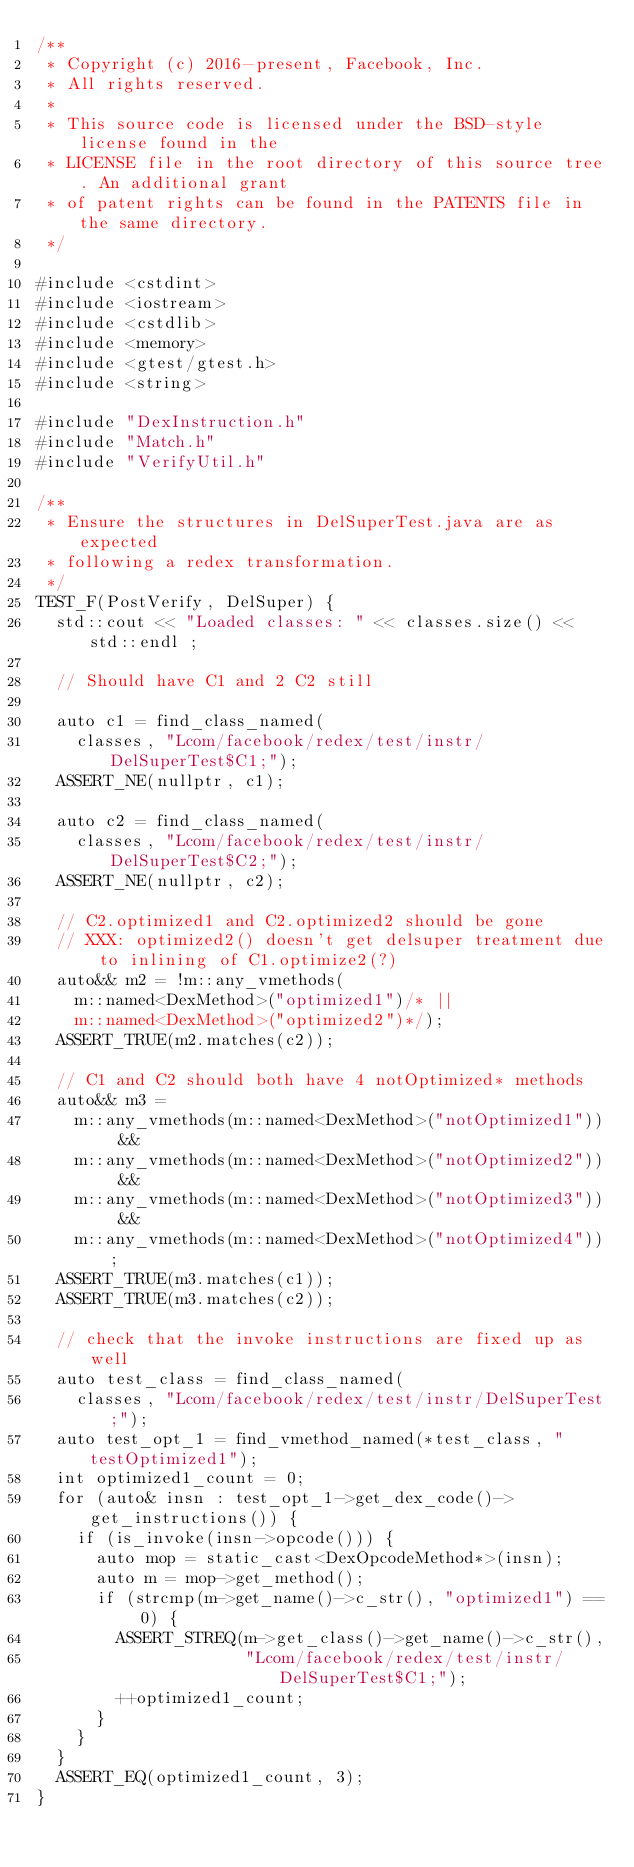Convert code to text. <code><loc_0><loc_0><loc_500><loc_500><_C++_>/**
 * Copyright (c) 2016-present, Facebook, Inc.
 * All rights reserved.
 *
 * This source code is licensed under the BSD-style license found in the
 * LICENSE file in the root directory of this source tree. An additional grant
 * of patent rights can be found in the PATENTS file in the same directory.
 */

#include <cstdint>
#include <iostream>
#include <cstdlib>
#include <memory>
#include <gtest/gtest.h>
#include <string>

#include "DexInstruction.h"
#include "Match.h"
#include "VerifyUtil.h"

/**
 * Ensure the structures in DelSuperTest.java are as expected
 * following a redex transformation.
 */
TEST_F(PostVerify, DelSuper) {
  std::cout << "Loaded classes: " << classes.size() << std::endl ;

  // Should have C1 and 2 C2 still

  auto c1 = find_class_named(
    classes, "Lcom/facebook/redex/test/instr/DelSuperTest$C1;");
  ASSERT_NE(nullptr, c1);

  auto c2 = find_class_named(
    classes, "Lcom/facebook/redex/test/instr/DelSuperTest$C2;");
  ASSERT_NE(nullptr, c2);

  // C2.optimized1 and C2.optimized2 should be gone
  // XXX: optimized2() doesn't get delsuper treatment due to inlining of C1.optimize2(?)
  auto&& m2 = !m::any_vmethods(
    m::named<DexMethod>("optimized1")/* ||
    m::named<DexMethod>("optimized2")*/);
  ASSERT_TRUE(m2.matches(c2));

  // C1 and C2 should both have 4 notOptimized* methods
  auto&& m3 =
    m::any_vmethods(m::named<DexMethod>("notOptimized1")) &&
    m::any_vmethods(m::named<DexMethod>("notOptimized2")) &&
    m::any_vmethods(m::named<DexMethod>("notOptimized3")) &&
    m::any_vmethods(m::named<DexMethod>("notOptimized4"));
  ASSERT_TRUE(m3.matches(c1));
  ASSERT_TRUE(m3.matches(c2));

  // check that the invoke instructions are fixed up as well
  auto test_class = find_class_named(
    classes, "Lcom/facebook/redex/test/instr/DelSuperTest;");
  auto test_opt_1 = find_vmethod_named(*test_class, "testOptimized1");
  int optimized1_count = 0;
  for (auto& insn : test_opt_1->get_dex_code()->get_instructions()) {
    if (is_invoke(insn->opcode())) {
      auto mop = static_cast<DexOpcodeMethod*>(insn);
      auto m = mop->get_method();
      if (strcmp(m->get_name()->c_str(), "optimized1") == 0) {
        ASSERT_STREQ(m->get_class()->get_name()->c_str(),
                     "Lcom/facebook/redex/test/instr/DelSuperTest$C1;");
        ++optimized1_count;
      }
    }
  }
  ASSERT_EQ(optimized1_count, 3);
}
</code> 